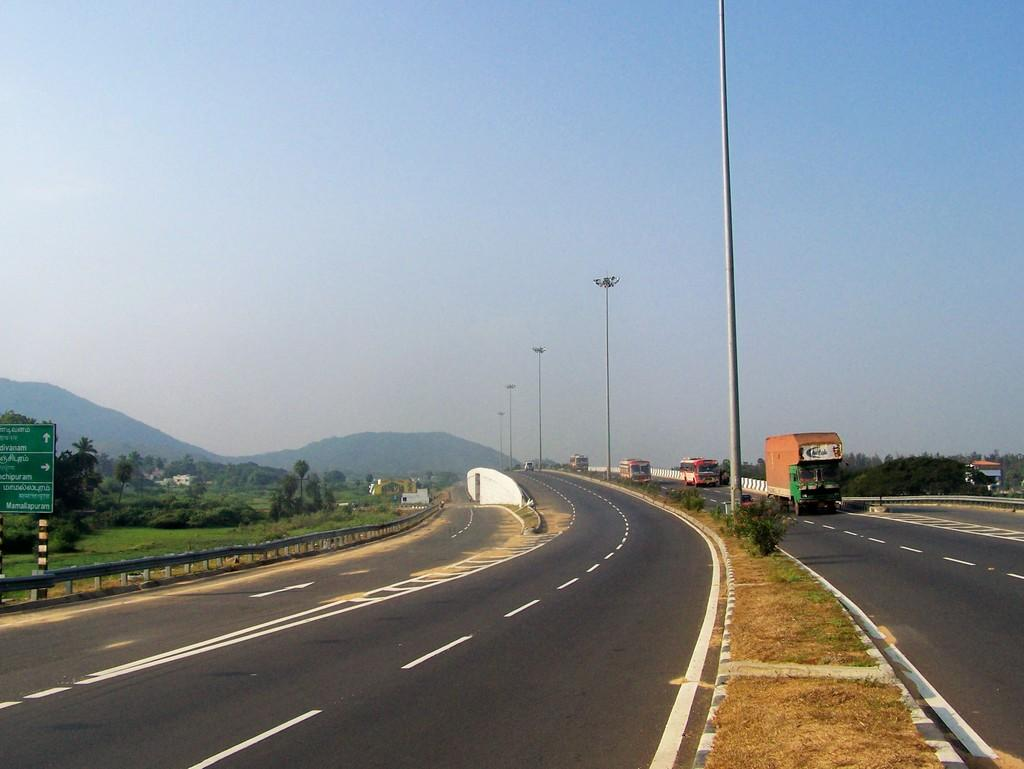What is the main feature in the center of the image? There is a road in the center of the image. What can be seen traveling on the road? Vehicles are present on the road. What objects are visible in the image besides the road and vehicles? There are poles, hills, trees, and the sky visible in the background of the image. Where is the board located in the image? The board is on the left side of the image. What type of judge is depicted on the board in the image? There is no judge depicted on the board in the image; it is a board with no visible text or image of a judge. 